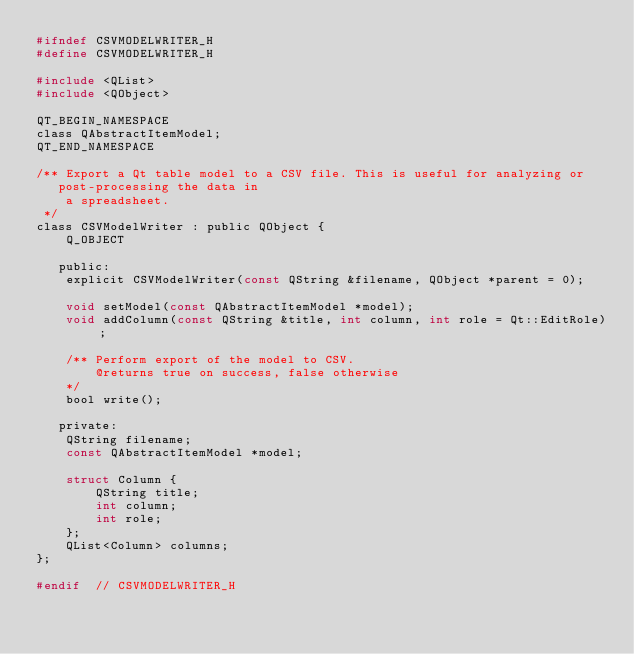Convert code to text. <code><loc_0><loc_0><loc_500><loc_500><_C_>#ifndef CSVMODELWRITER_H
#define CSVMODELWRITER_H

#include <QList>
#include <QObject>

QT_BEGIN_NAMESPACE
class QAbstractItemModel;
QT_END_NAMESPACE

/** Export a Qt table model to a CSV file. This is useful for analyzing or
   post-processing the data in
    a spreadsheet.
 */
class CSVModelWriter : public QObject {
    Q_OBJECT

   public:
    explicit CSVModelWriter(const QString &filename, QObject *parent = 0);

    void setModel(const QAbstractItemModel *model);
    void addColumn(const QString &title, int column, int role = Qt::EditRole);

    /** Perform export of the model to CSV.
        @returns true on success, false otherwise
    */
    bool write();

   private:
    QString filename;
    const QAbstractItemModel *model;

    struct Column {
        QString title;
        int column;
        int role;
    };
    QList<Column> columns;
};

#endif  // CSVMODELWRITER_H
</code> 